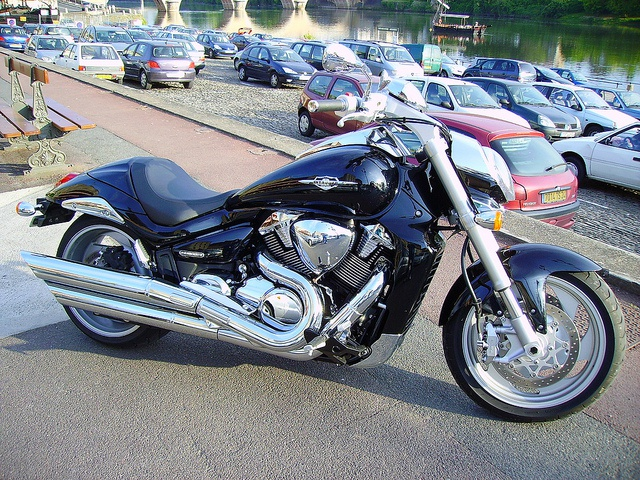Describe the objects in this image and their specific colors. I can see motorcycle in purple, black, lightgray, darkgray, and gray tones, car in purple, lightgray, lightblue, and darkgray tones, car in purple, lavender, lightblue, pink, and lightpink tones, car in purple, lightblue, darkgray, black, and lightgray tones, and bench in purple, lightgray, darkgray, gray, and black tones in this image. 